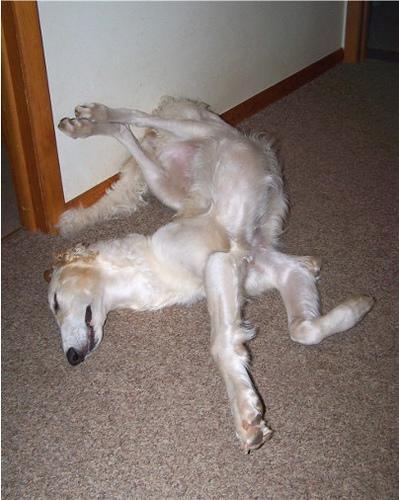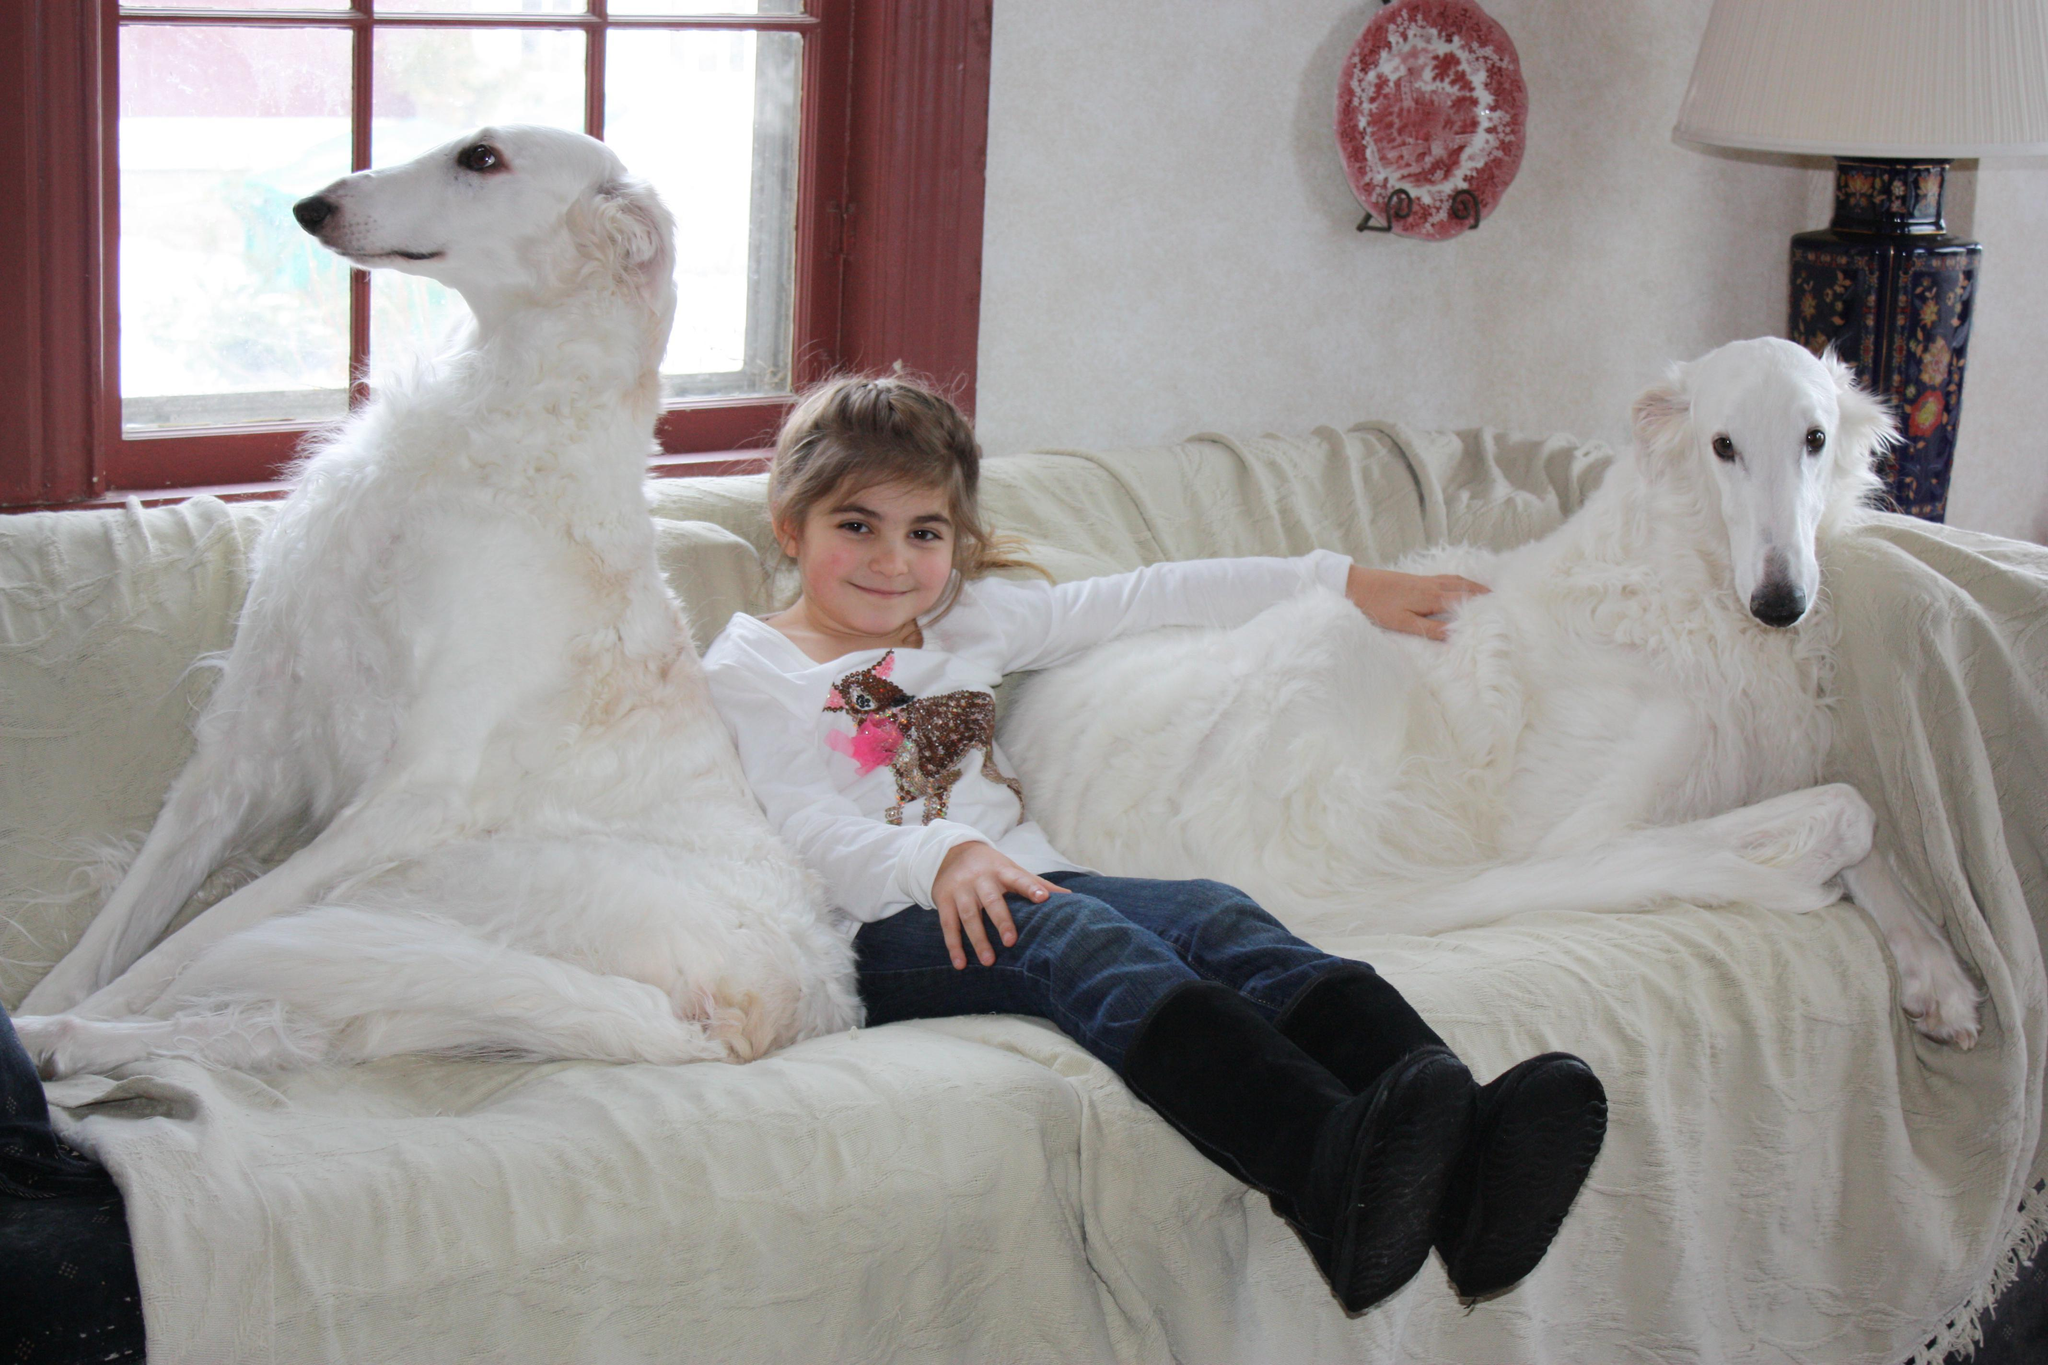The first image is the image on the left, the second image is the image on the right. Given the left and right images, does the statement "There are at least two white dogs in the right image." hold true? Answer yes or no. Yes. The first image is the image on the left, the second image is the image on the right. Analyze the images presented: Is the assertion "there is a female sitting with a dog in one of the images" valid? Answer yes or no. Yes. 